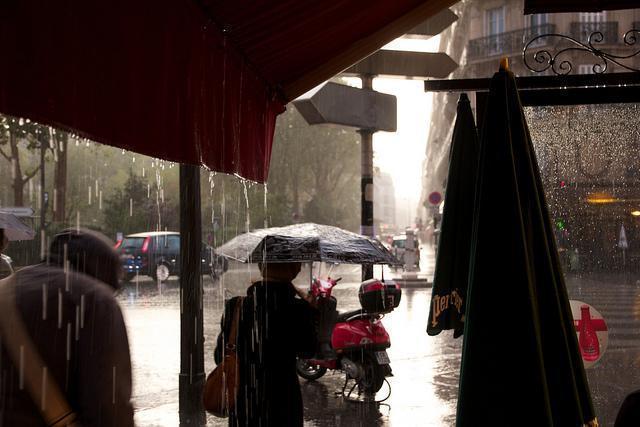Where does this water come from?
Indicate the correct response by choosing from the four available options to answer the question.
Options: Hose, sky, water nozzle, fire hydrant. Sky. 